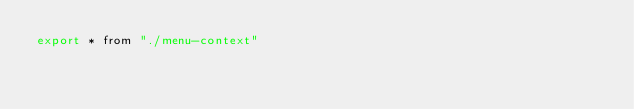Convert code to text. <code><loc_0><loc_0><loc_500><loc_500><_JavaScript_>export * from "./menu-context"
</code> 